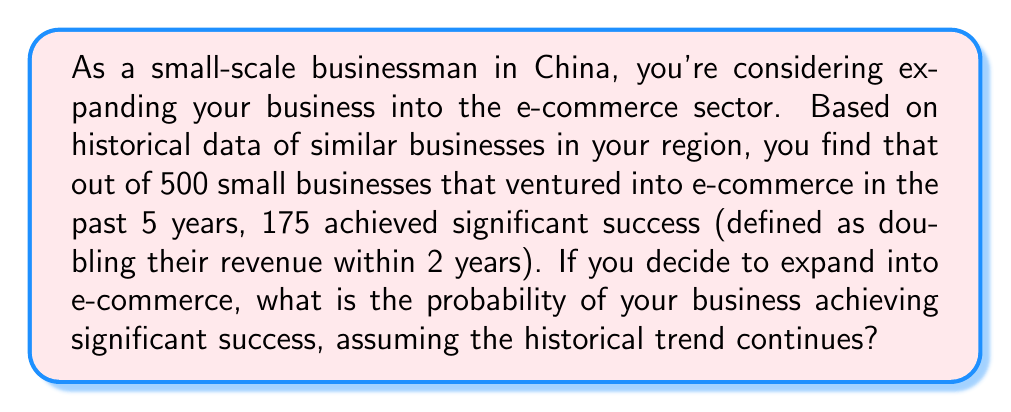Can you answer this question? To solve this problem, we need to use the concept of empirical probability. Empirical probability is based on observed data and is calculated as the number of favorable outcomes divided by the total number of trials.

Let's define our events:
- A: The event of achieving significant success in e-commerce

Given:
- Total number of businesses that ventured into e-commerce: 500
- Number of businesses that achieved significant success: 175

The probability of success can be calculated as follows:

$$ P(A) = \frac{\text{Number of successful businesses}}{\text{Total number of businesses}} $$

$$ P(A) = \frac{175}{500} $$

To simplify this fraction, we can divide both the numerator and denominator by their greatest common divisor (GCD). The GCD of 175 and 500 is 25.

$$ P(A) = \frac{175 \div 25}{500 \div 25} = \frac{7}{20} $$

To convert this to a percentage:

$$ P(A) = \frac{7}{20} \times 100\% = 35\% $$

Therefore, based on the historical data, the probability of achieving significant success in e-commerce is 35% or 0.35.
Answer: $\frac{7}{20}$ or 0.35 or 35% 